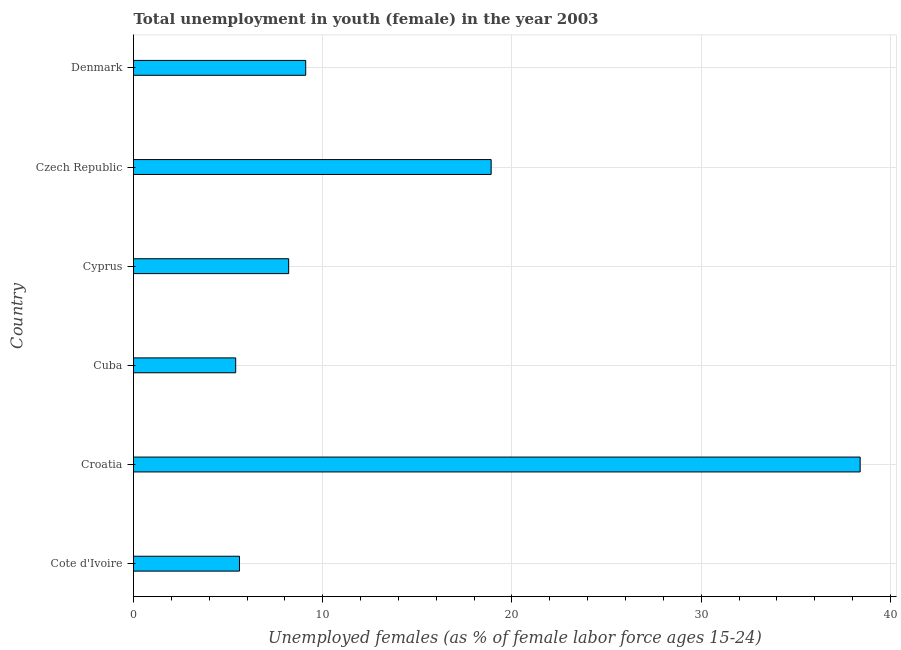Does the graph contain any zero values?
Offer a very short reply. No. Does the graph contain grids?
Give a very brief answer. Yes. What is the title of the graph?
Offer a very short reply. Total unemployment in youth (female) in the year 2003. What is the label or title of the X-axis?
Provide a short and direct response. Unemployed females (as % of female labor force ages 15-24). What is the unemployed female youth population in Cuba?
Offer a terse response. 5.4. Across all countries, what is the maximum unemployed female youth population?
Offer a very short reply. 38.4. Across all countries, what is the minimum unemployed female youth population?
Your answer should be compact. 5.4. In which country was the unemployed female youth population maximum?
Your answer should be compact. Croatia. In which country was the unemployed female youth population minimum?
Make the answer very short. Cuba. What is the sum of the unemployed female youth population?
Your answer should be very brief. 85.6. What is the difference between the unemployed female youth population in Cyprus and Czech Republic?
Your answer should be very brief. -10.7. What is the average unemployed female youth population per country?
Offer a very short reply. 14.27. What is the median unemployed female youth population?
Give a very brief answer. 8.65. In how many countries, is the unemployed female youth population greater than 32 %?
Your answer should be compact. 1. What is the ratio of the unemployed female youth population in Croatia to that in Cuba?
Your answer should be very brief. 7.11. What is the difference between the highest and the second highest unemployed female youth population?
Offer a terse response. 19.5. How many bars are there?
Make the answer very short. 6. What is the Unemployed females (as % of female labor force ages 15-24) in Cote d'Ivoire?
Make the answer very short. 5.6. What is the Unemployed females (as % of female labor force ages 15-24) in Croatia?
Provide a short and direct response. 38.4. What is the Unemployed females (as % of female labor force ages 15-24) in Cuba?
Your answer should be very brief. 5.4. What is the Unemployed females (as % of female labor force ages 15-24) in Cyprus?
Make the answer very short. 8.2. What is the Unemployed females (as % of female labor force ages 15-24) of Czech Republic?
Ensure brevity in your answer.  18.9. What is the Unemployed females (as % of female labor force ages 15-24) of Denmark?
Give a very brief answer. 9.1. What is the difference between the Unemployed females (as % of female labor force ages 15-24) in Cote d'Ivoire and Croatia?
Make the answer very short. -32.8. What is the difference between the Unemployed females (as % of female labor force ages 15-24) in Cote d'Ivoire and Cyprus?
Keep it short and to the point. -2.6. What is the difference between the Unemployed females (as % of female labor force ages 15-24) in Cote d'Ivoire and Czech Republic?
Give a very brief answer. -13.3. What is the difference between the Unemployed females (as % of female labor force ages 15-24) in Cote d'Ivoire and Denmark?
Keep it short and to the point. -3.5. What is the difference between the Unemployed females (as % of female labor force ages 15-24) in Croatia and Cyprus?
Provide a short and direct response. 30.2. What is the difference between the Unemployed females (as % of female labor force ages 15-24) in Croatia and Czech Republic?
Your response must be concise. 19.5. What is the difference between the Unemployed females (as % of female labor force ages 15-24) in Croatia and Denmark?
Make the answer very short. 29.3. What is the difference between the Unemployed females (as % of female labor force ages 15-24) in Cuba and Cyprus?
Provide a succinct answer. -2.8. What is the difference between the Unemployed females (as % of female labor force ages 15-24) in Cuba and Czech Republic?
Keep it short and to the point. -13.5. What is the difference between the Unemployed females (as % of female labor force ages 15-24) in Cuba and Denmark?
Offer a very short reply. -3.7. What is the difference between the Unemployed females (as % of female labor force ages 15-24) in Cyprus and Denmark?
Your response must be concise. -0.9. What is the ratio of the Unemployed females (as % of female labor force ages 15-24) in Cote d'Ivoire to that in Croatia?
Keep it short and to the point. 0.15. What is the ratio of the Unemployed females (as % of female labor force ages 15-24) in Cote d'Ivoire to that in Cyprus?
Provide a short and direct response. 0.68. What is the ratio of the Unemployed females (as % of female labor force ages 15-24) in Cote d'Ivoire to that in Czech Republic?
Provide a succinct answer. 0.3. What is the ratio of the Unemployed females (as % of female labor force ages 15-24) in Cote d'Ivoire to that in Denmark?
Your answer should be compact. 0.61. What is the ratio of the Unemployed females (as % of female labor force ages 15-24) in Croatia to that in Cuba?
Offer a very short reply. 7.11. What is the ratio of the Unemployed females (as % of female labor force ages 15-24) in Croatia to that in Cyprus?
Ensure brevity in your answer.  4.68. What is the ratio of the Unemployed females (as % of female labor force ages 15-24) in Croatia to that in Czech Republic?
Provide a succinct answer. 2.03. What is the ratio of the Unemployed females (as % of female labor force ages 15-24) in Croatia to that in Denmark?
Keep it short and to the point. 4.22. What is the ratio of the Unemployed females (as % of female labor force ages 15-24) in Cuba to that in Cyprus?
Ensure brevity in your answer.  0.66. What is the ratio of the Unemployed females (as % of female labor force ages 15-24) in Cuba to that in Czech Republic?
Keep it short and to the point. 0.29. What is the ratio of the Unemployed females (as % of female labor force ages 15-24) in Cuba to that in Denmark?
Give a very brief answer. 0.59. What is the ratio of the Unemployed females (as % of female labor force ages 15-24) in Cyprus to that in Czech Republic?
Your response must be concise. 0.43. What is the ratio of the Unemployed females (as % of female labor force ages 15-24) in Cyprus to that in Denmark?
Provide a short and direct response. 0.9. What is the ratio of the Unemployed females (as % of female labor force ages 15-24) in Czech Republic to that in Denmark?
Make the answer very short. 2.08. 